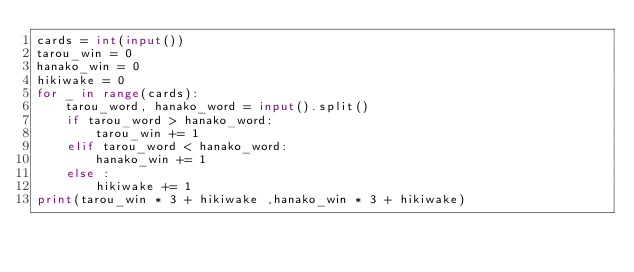Convert code to text. <code><loc_0><loc_0><loc_500><loc_500><_Python_>cards = int(input())
tarou_win = 0
hanako_win = 0
hikiwake = 0
for _ in range(cards):
    tarou_word, hanako_word = input().split() 
    if tarou_word > hanako_word:
        tarou_win += 1
    elif tarou_word < hanako_word:
        hanako_win += 1
    else :
        hikiwake += 1
print(tarou_win * 3 + hikiwake ,hanako_win * 3 + hikiwake)
</code> 